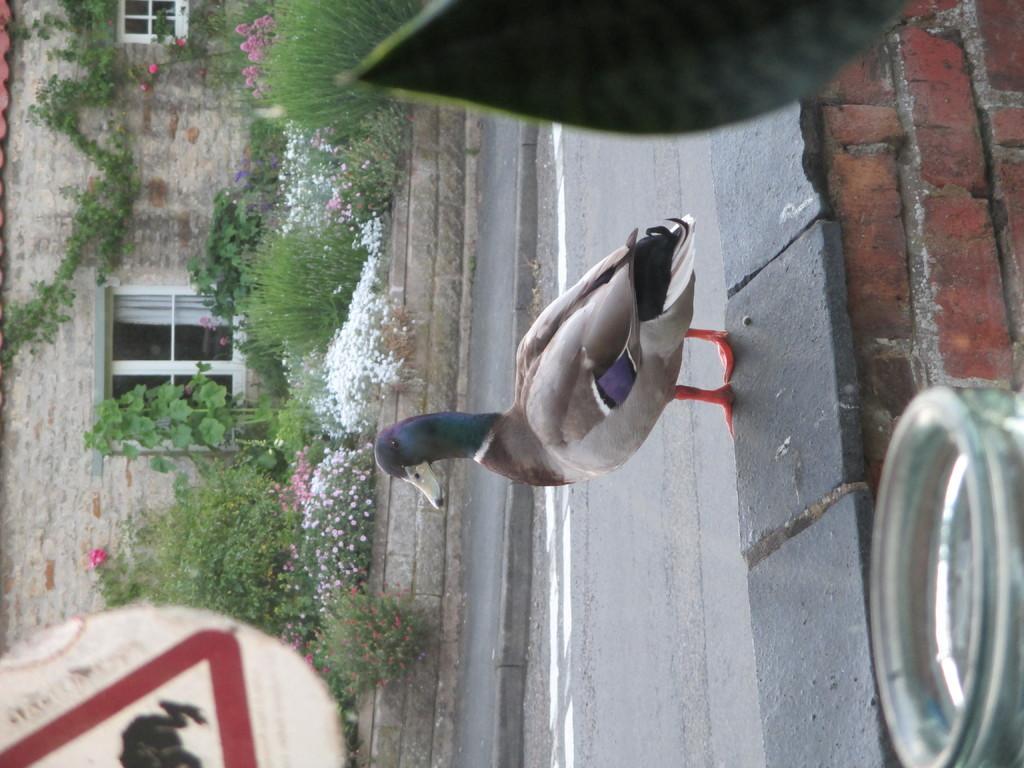In one or two sentences, can you explain what this image depicts? In the center of the image there is a duck on the brick wall. There is a road. In the background there are plants. There is a sign board and there is a building with the glass window. 